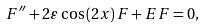Convert formula to latex. <formula><loc_0><loc_0><loc_500><loc_500>F ^ { \prime \prime } + 2 \varepsilon \cos \left ( 2 x \right ) F + E F = 0 ,</formula> 